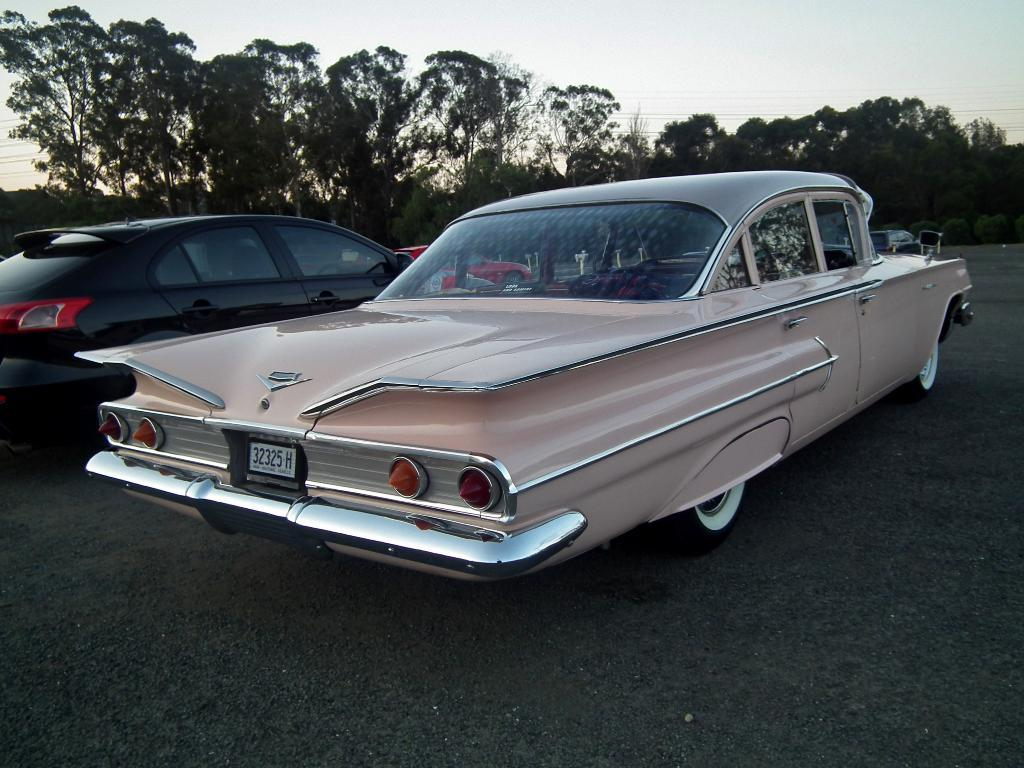What is the main subject of the image? The main subject of the image is cars. Where are the cars located in the image? The cars are in the center of the image. What can be seen in the background of the image? There are trees in the background of the image. What is visible at the top of the image? The sky is visible at the top of the image. Can you see any wounds on the trees in the image? There are no wounds visible on the trees in the image; the trees appear healthy and undamaged. 